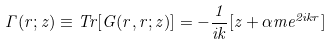<formula> <loc_0><loc_0><loc_500><loc_500>\Gamma ( r ; z ) \equiv T r [ G ( r , r ; z ) ] = - \frac { 1 } { i k } [ z + \alpha m e ^ { 2 i k r } ]</formula> 